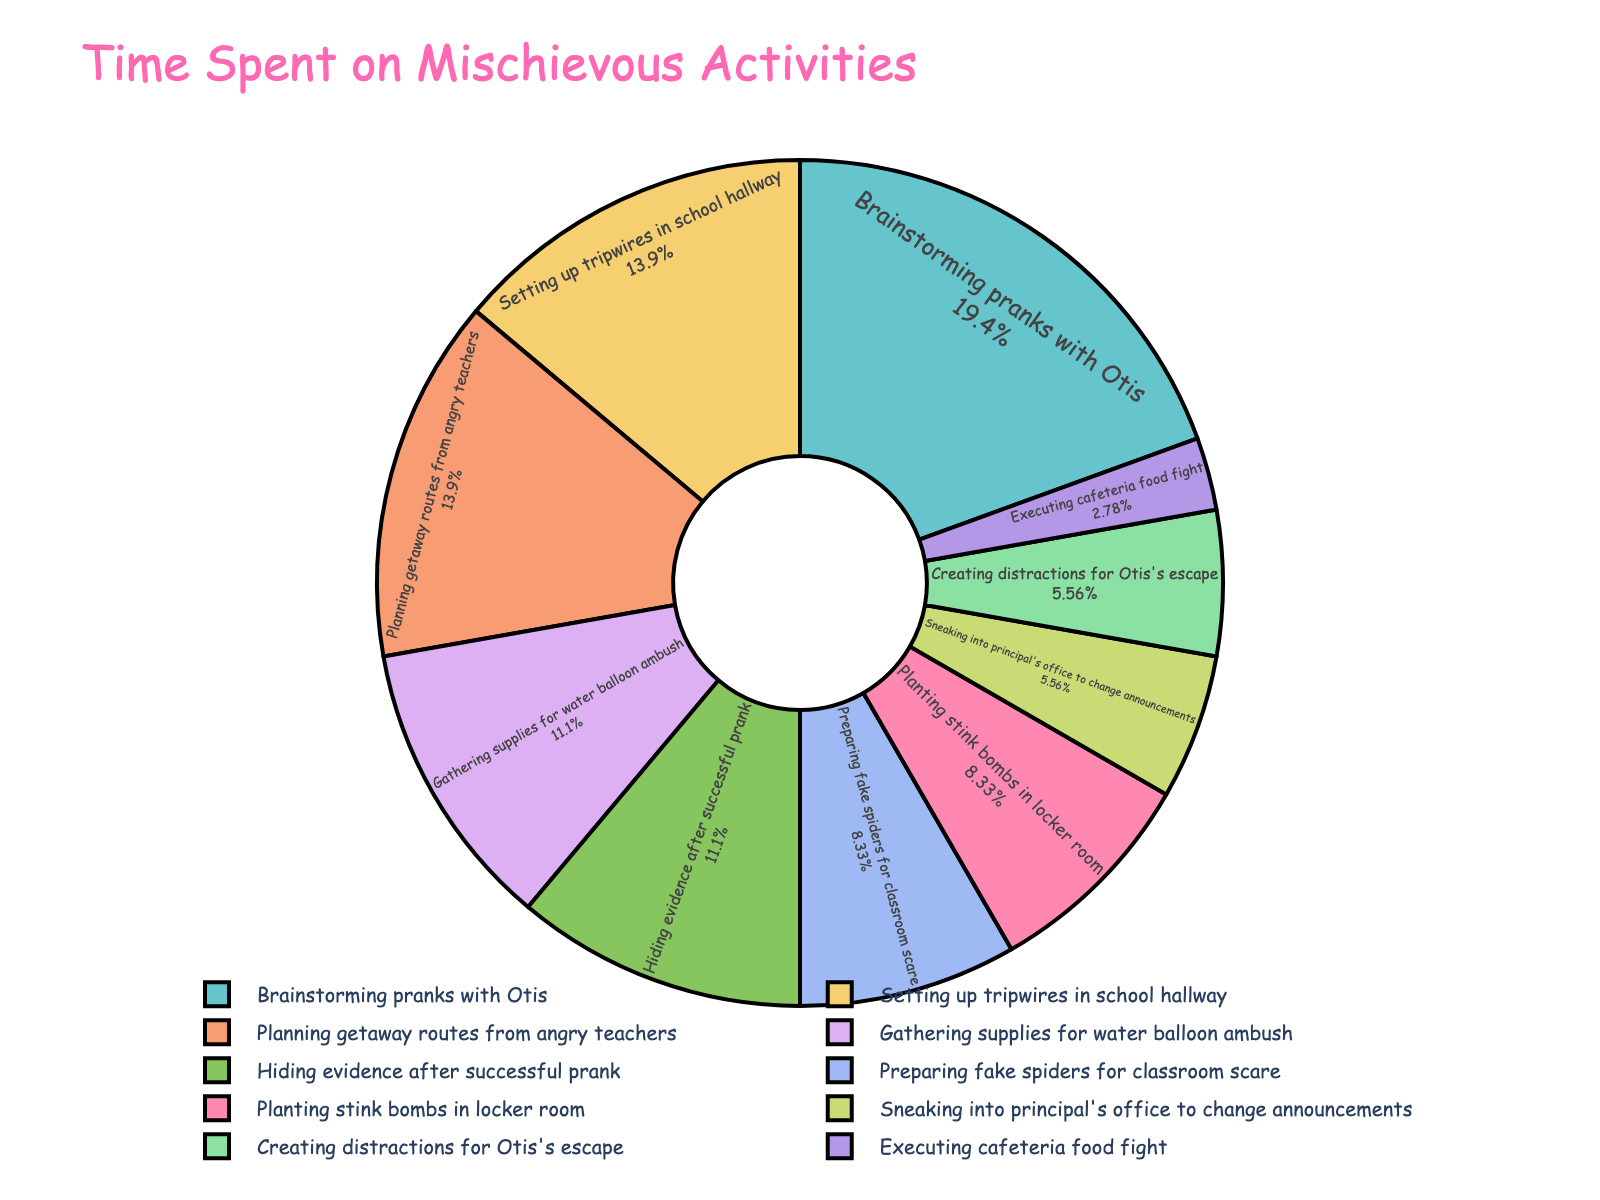Which stage takes the most time? By looking at the pie chart, identify the largest segment.
Answer: Brainstorming pranks with Otis Which stage takes the least amount of time? By visually identifying the smallest segment in the pie chart.
Answer: Executing cafeteria food fight How many hours, in total, are spent on executing pranks (excluding planning and preparation)? Sum the hours for execution stages: Executing cafeteria food fight (0.5), Sneaking into principal's office to change announcements (1), Planting stink bombs in locker room (1.5), Creating distractions for Otis's escape (1). Total = 0.5 + 1 + 1.5 + 1.
Answer: 4 How does the time spent on hiding evidence compare to planning getaway routes? Compare the sizes of the segments or sum the hours: Hiding evidence after successful prank (2), Planning getaway routes from angry teachers (2.5).
Answer: Planning getaway routes take more time What percentage of the total time is spent on setting up tripwires in the school hallway? Identify the percentage given inside the segment for setting up tripwires in the pie chart.
Answer: Approximately 12.5% What is the combined time spent on preparation and escape strategies? Sum the hours for preparation stages: Gathering supplies for water balloon ambush (2), Preparing fake spiders for classroom scare (1.5), Setting up tripwires in school hallway (2.5), Hiding evidence after successful prank (2). Sum the hours for escape strategies: Creating distractions for Otis's escape (1), Planning getaway routes from angry teachers (2.5). Total = 2 + 1.5 + 2.5 + 2 + 1 + 2.5.
Answer: 11.5 Which activities take more than 2 hours but less than 3 hours? Identify the segments in the pie chart that fall within the specified range.
Answer: Brainstorming pranks with Otis, Setting up tripwires in school hallway, Planning getaway routes from angry teachers Is the time spent on gathering supplies for the water balloon ambush more or less than the time spent on sneaking into the principal's office? Compare the segments of the corresponding activities in the pie chart: Gathering supplies for water balloon ambush (2), Sneaking into principal's office to change announcements (1).
Answer: More What portion of the time is spent on creating distractions for Otis's escape, in relation to the total prank planning time? Identify and compare the segment for creating distractions with the entire pie chart (percentage inside the segment for creating distractions as part of the total).
Answer: 6.25% 